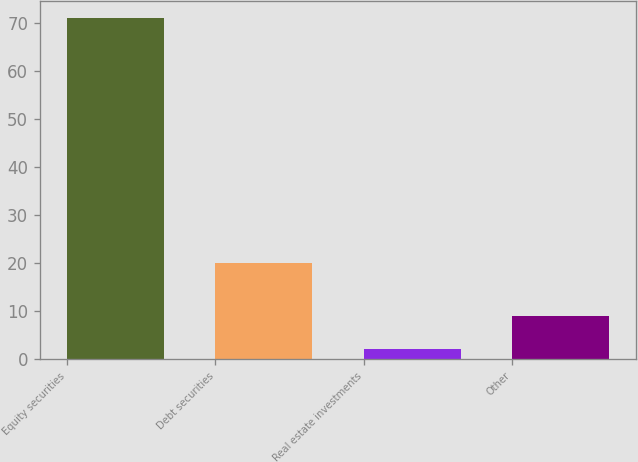Convert chart to OTSL. <chart><loc_0><loc_0><loc_500><loc_500><bar_chart><fcel>Equity securities<fcel>Debt securities<fcel>Real estate investments<fcel>Other<nl><fcel>71<fcel>20<fcel>2<fcel>8.9<nl></chart> 